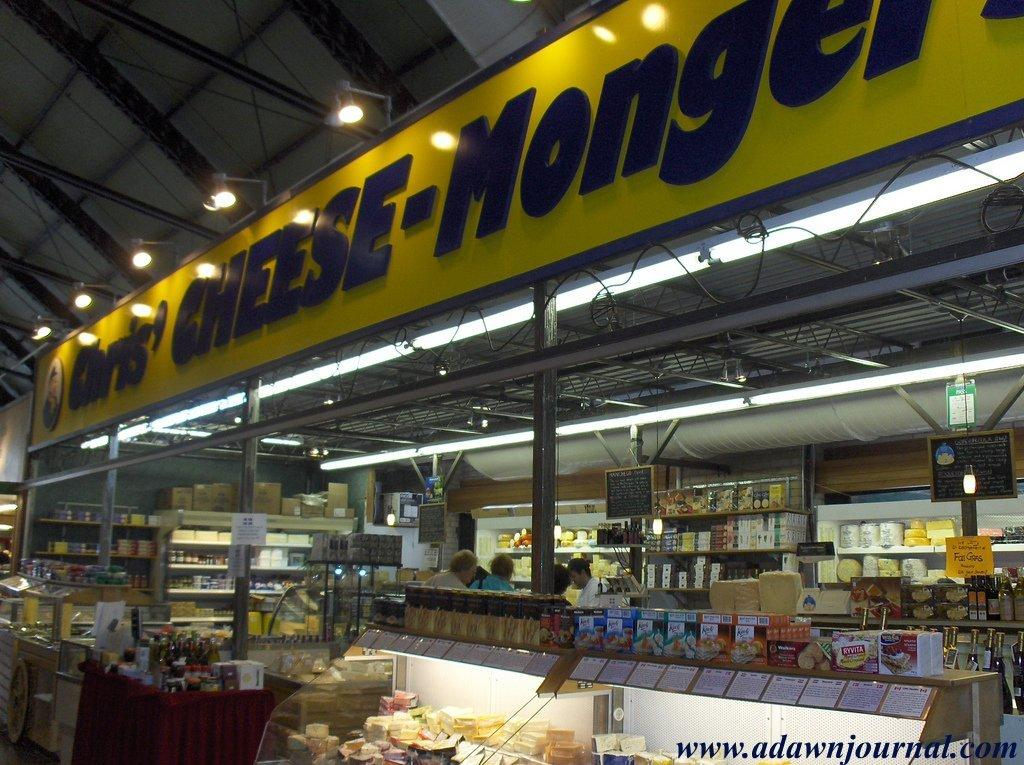<image>
Describe the image concisely. Chris' Cheese is on a sign above a market. 